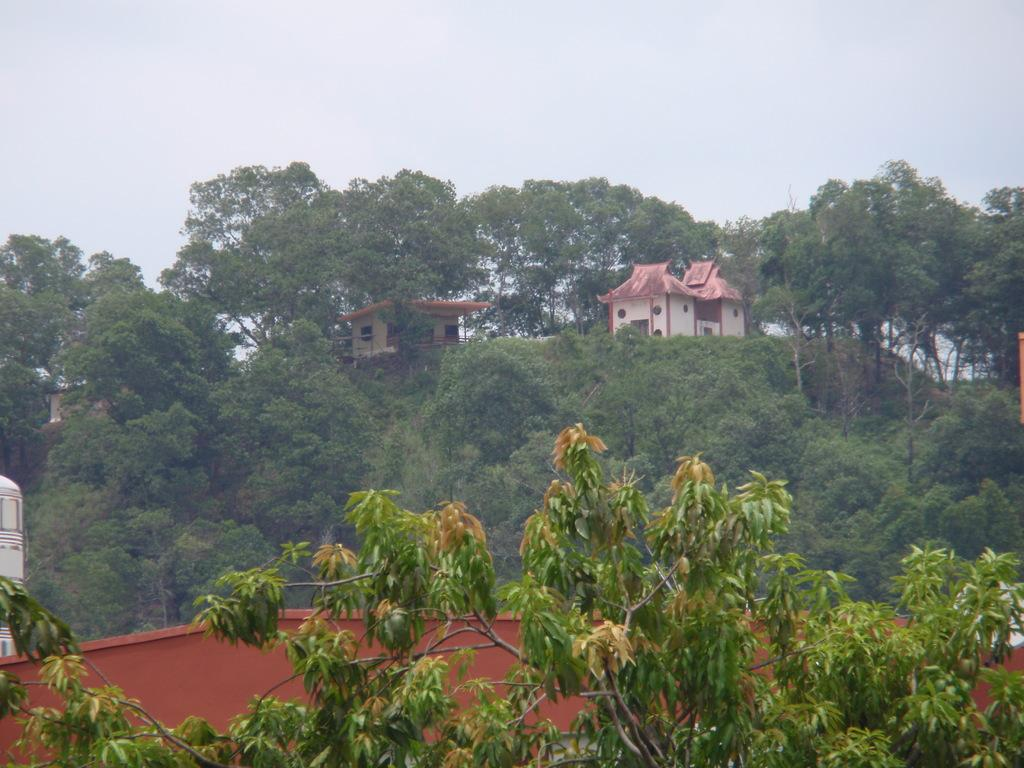What type of natural elements can be seen in the image? There are trees in the image. What type of man-made structures are present in the image? There are houses in the image. What color is the spy's hat in the image? There is no spy or hat present in the image. What type of learning can be observed taking place in the image? There is no learning activity depicted in the image. 